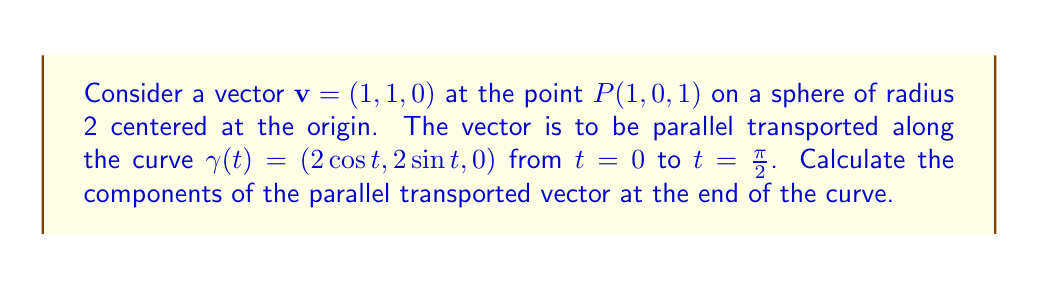Could you help me with this problem? Let's approach this step-by-step:

1) First, we need to understand that parallel transport preserves the angle between the vector and the curve, and the vector's magnitude.

2) The tangent vector to the curve $\gamma(t)$ is:
   $$\mathbf{T}(t) = (-2\sin t, 2\cos t, 0)$$

3) The normal vector to the sphere at any point $(x, y, z)$ is simply $(x, y, z)$. So, the normal vector along the curve is:
   $$\mathbf{N}(t) = (2\cos t, 2\sin t, 0)$$

4) We need to find a vector $\mathbf{w}(t)$ that is perpendicular to both $\mathbf{T}(t)$ and $\mathbf{N}(t)$:
   $$\mathbf{w}(t) = \mathbf{T}(t) \times \mathbf{N}(t) = (0, 0, 4)$$

5) Now, we can express our initial vector $\mathbf{v}$ in terms of $\mathbf{T}(0)$, $\mathbf{N}(0)$, and $\mathbf{w}(0)$:
   $$\mathbf{v} = a\mathbf{T}(0) + b\mathbf{N}(0) + c\mathbf{w}(0)$$
   
   where $a$, $b$, and $c$ are scalars we need to determine.

6) At $t = 0$, $\mathbf{T}(0) = (0, 2, 0)$, $\mathbf{N}(0) = (2, 0, 0)$, and $\mathbf{w}(0) = (0, 0, 4)$.

7) Solving the equation:
   $$(1, 1, 0) = a(0, 2, 0) + b(2, 0, 0) + c(0, 0, 4)$$
   
   We get: $a = \frac{1}{2}$, $b = \frac{1}{2}$, $c = 0$

8) The parallel transported vector at any point $t$ will have the same coefficients:
   $$\mathbf{v}(t) = \frac{1}{2}\mathbf{T}(t) + \frac{1}{2}\mathbf{N}(t) + 0\mathbf{w}(t)$$

9) At $t = \frac{\pi}{2}$:
   $$\mathbf{T}(\frac{\pi}{2}) = (-2, 0, 0)$$
   $$\mathbf{N}(\frac{\pi}{2}) = (0, 2, 0)$$

10) Therefore, the parallel transported vector at $t = \frac{\pi}{2}$ is:
    $$\mathbf{v}(\frac{\pi}{2}) = \frac{1}{2}(-2, 0, 0) + \frac{1}{2}(0, 2, 0) = (-1, 1, 0)$$
Answer: $(-1, 1, 0)$ 